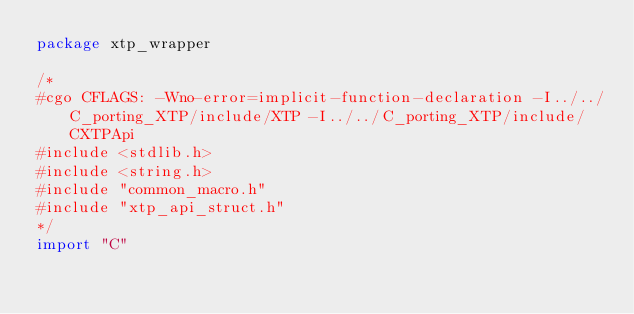Convert code to text. <code><loc_0><loc_0><loc_500><loc_500><_Go_>package xtp_wrapper

/*
#cgo CFLAGS: -Wno-error=implicit-function-declaration -I../../C_porting_XTP/include/XTP -I../../C_porting_XTP/include/CXTPApi
#include <stdlib.h>
#include <string.h>
#include "common_macro.h"
#include "xtp_api_struct.h"
*/
import "C"
</code> 